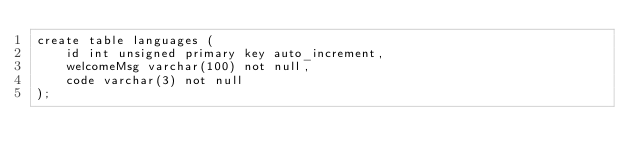<code> <loc_0><loc_0><loc_500><loc_500><_SQL_>create table languages (
    id int unsigned primary key auto_increment,
    welcomeMsg varchar(100) not null,
    code varchar(3) not null
);</code> 